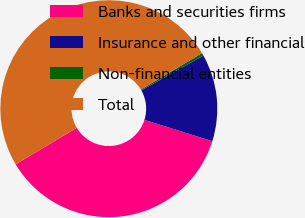Convert chart. <chart><loc_0><loc_0><loc_500><loc_500><pie_chart><fcel>Banks and securities firms<fcel>Insurance and other financial<fcel>Non-financial entities<fcel>Total<nl><fcel>36.6%<fcel>12.99%<fcel>0.41%<fcel>50.0%<nl></chart> 